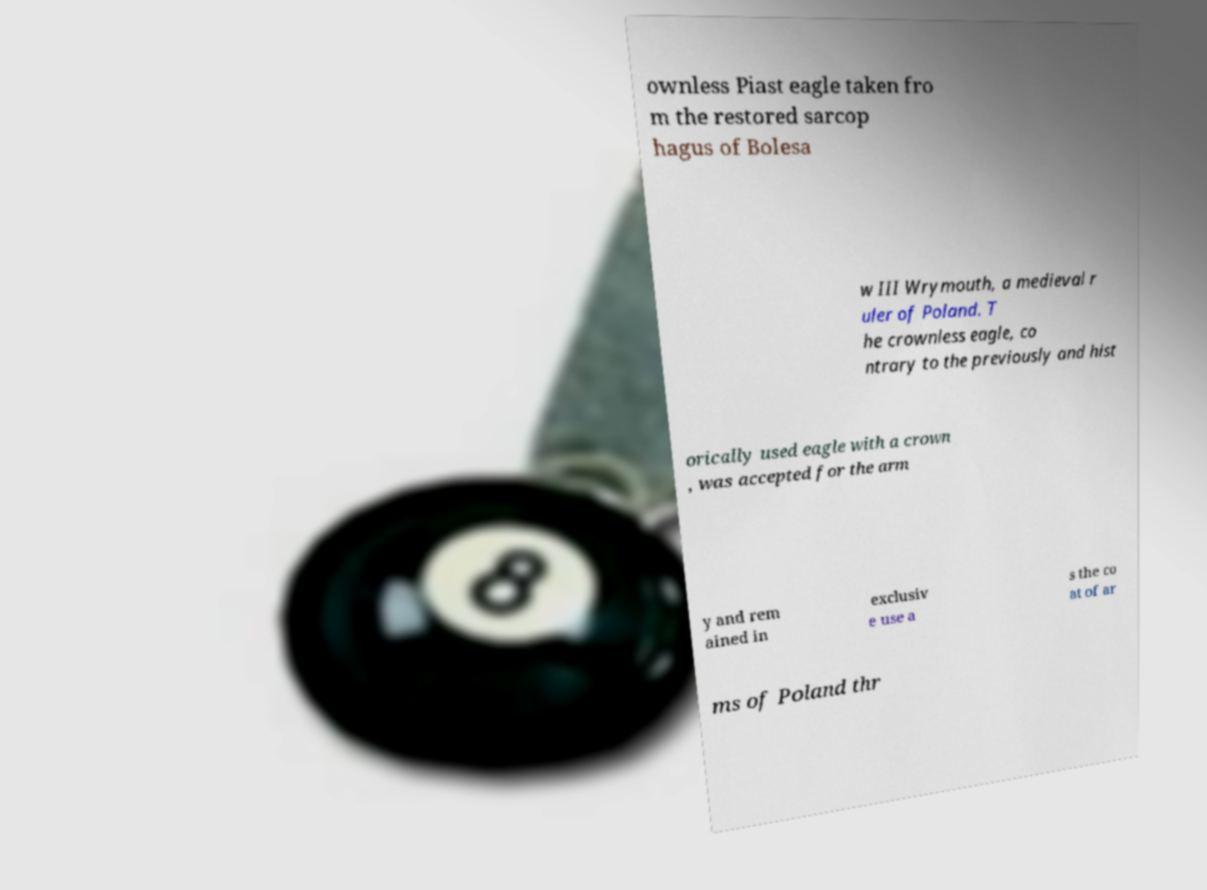What messages or text are displayed in this image? I need them in a readable, typed format. ownless Piast eagle taken fro m the restored sarcop hagus of Bolesa w III Wrymouth, a medieval r uler of Poland. T he crownless eagle, co ntrary to the previously and hist orically used eagle with a crown , was accepted for the arm y and rem ained in exclusiv e use a s the co at of ar ms of Poland thr 